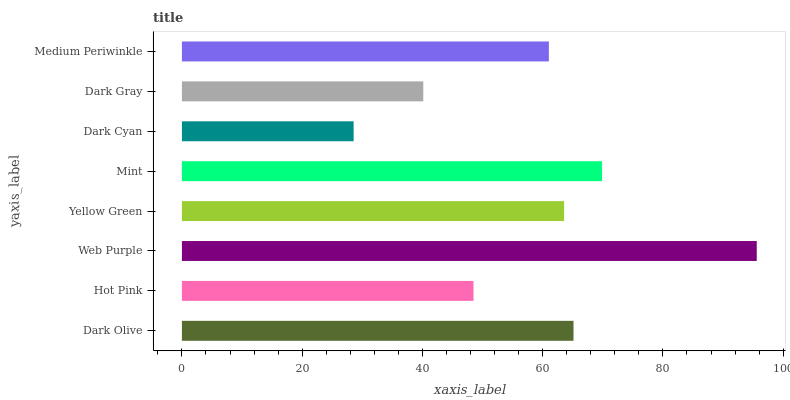Is Dark Cyan the minimum?
Answer yes or no. Yes. Is Web Purple the maximum?
Answer yes or no. Yes. Is Hot Pink the minimum?
Answer yes or no. No. Is Hot Pink the maximum?
Answer yes or no. No. Is Dark Olive greater than Hot Pink?
Answer yes or no. Yes. Is Hot Pink less than Dark Olive?
Answer yes or no. Yes. Is Hot Pink greater than Dark Olive?
Answer yes or no. No. Is Dark Olive less than Hot Pink?
Answer yes or no. No. Is Yellow Green the high median?
Answer yes or no. Yes. Is Medium Periwinkle the low median?
Answer yes or no. Yes. Is Web Purple the high median?
Answer yes or no. No. Is Mint the low median?
Answer yes or no. No. 